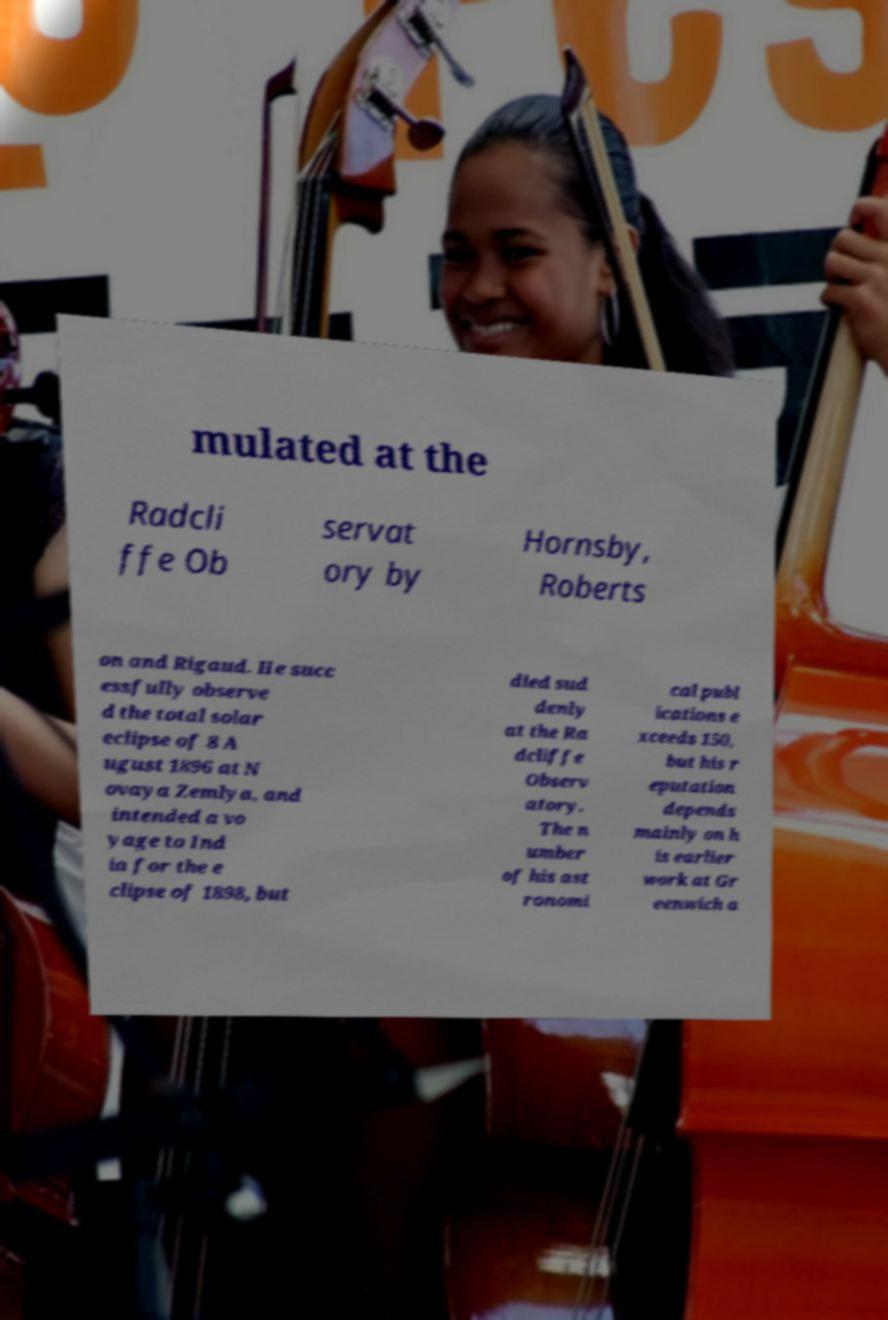For documentation purposes, I need the text within this image transcribed. Could you provide that? mulated at the Radcli ffe Ob servat ory by Hornsby, Roberts on and Rigaud. He succ essfully observe d the total solar eclipse of 8 A ugust 1896 at N ovaya Zemlya, and intended a vo yage to Ind ia for the e clipse of 1898, but died sud denly at the Ra dcliffe Observ atory. The n umber of his ast ronomi cal publ ications e xceeds 150, but his r eputation depends mainly on h is earlier work at Gr eenwich a 